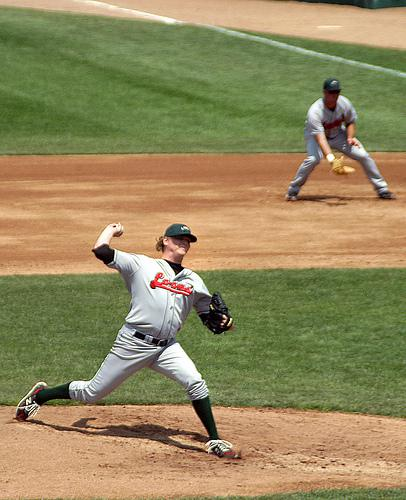Question: what is the man in front throwing?
Choices:
A. Stuffed Animal.
B. Pillow.
C. Baseball.
D. Toy.
Answer with the letter. Answer: C Question: what position is the man on the right?
Choices:
A. Shortstop.
B. Catcher.
C. First base.
D. Pitcher.
Answer with the letter. Answer: C Question: what do the men have on their hands?
Choices:
A. Paint.
B. Dirt.
C. Baseball gloves.
D. Mittens.
Answer with the letter. Answer: C Question: how many players?
Choices:
A. Three.
B. Four.
C. Two.
D. Five.
Answer with the letter. Answer: C Question: who has the ball?
Choices:
A. The referee.
B. The coach.
C. Pitcher.
D. The quarterback.
Answer with the letter. Answer: C Question: what color are the baseball jerseys?
Choices:
A. White.
B. Black.
C. Blue.
D. Gray.
Answer with the letter. Answer: D Question: what do the men have on their heads?
Choices:
A. Wigs.
B. Hats.
C. Hoods.
D. Sunscreen.
Answer with the letter. Answer: B 